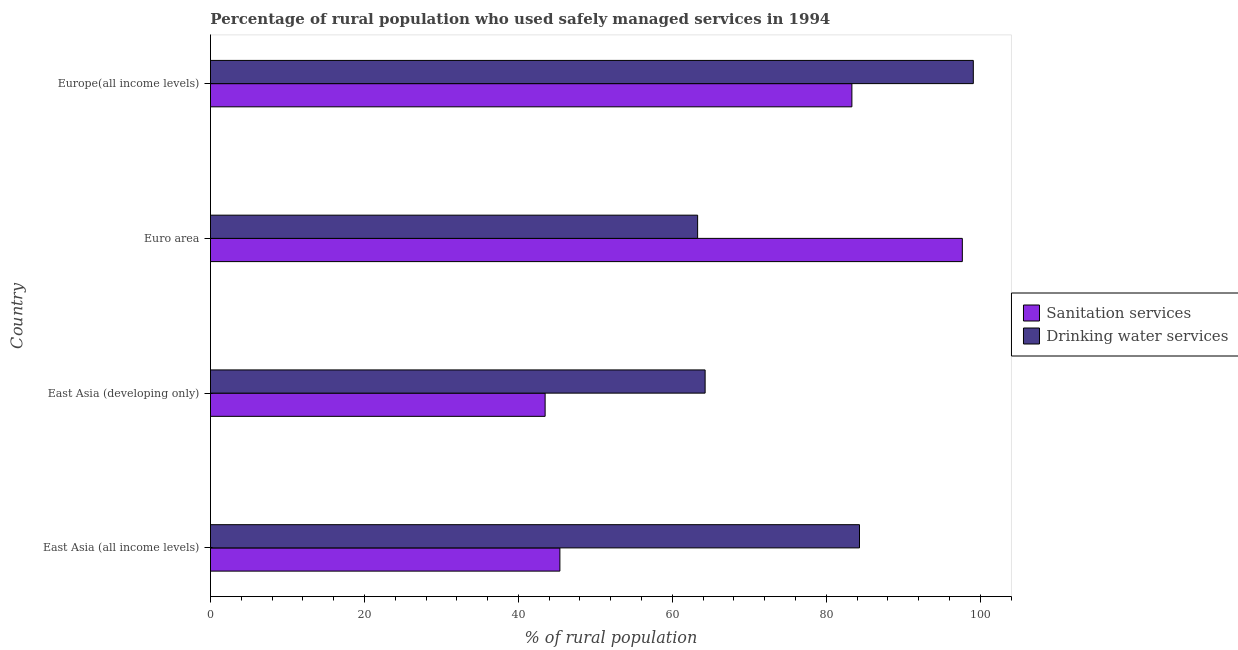How many different coloured bars are there?
Offer a very short reply. 2. Are the number of bars per tick equal to the number of legend labels?
Keep it short and to the point. Yes. What is the label of the 1st group of bars from the top?
Keep it short and to the point. Europe(all income levels). What is the percentage of rural population who used sanitation services in East Asia (developing only)?
Ensure brevity in your answer.  43.47. Across all countries, what is the maximum percentage of rural population who used sanitation services?
Ensure brevity in your answer.  97.67. Across all countries, what is the minimum percentage of rural population who used drinking water services?
Provide a succinct answer. 63.29. In which country was the percentage of rural population who used sanitation services maximum?
Your answer should be very brief. Euro area. What is the total percentage of rural population who used sanitation services in the graph?
Keep it short and to the point. 269.87. What is the difference between the percentage of rural population who used drinking water services in East Asia (developing only) and that in Europe(all income levels)?
Provide a succinct answer. -34.84. What is the difference between the percentage of rural population who used sanitation services in Europe(all income levels) and the percentage of rural population who used drinking water services in Euro area?
Give a very brief answer. 20.04. What is the average percentage of rural population who used drinking water services per country?
Your response must be concise. 77.74. What is the difference between the percentage of rural population who used drinking water services and percentage of rural population who used sanitation services in East Asia (developing only)?
Your answer should be compact. 20.79. In how many countries, is the percentage of rural population who used drinking water services greater than 96 %?
Provide a succinct answer. 1. What is the ratio of the percentage of rural population who used sanitation services in East Asia (all income levels) to that in Euro area?
Provide a succinct answer. 0.47. Is the percentage of rural population who used drinking water services in East Asia (developing only) less than that in Euro area?
Give a very brief answer. No. What is the difference between the highest and the second highest percentage of rural population who used sanitation services?
Your response must be concise. 14.35. What is the difference between the highest and the lowest percentage of rural population who used drinking water services?
Your answer should be compact. 35.82. In how many countries, is the percentage of rural population who used drinking water services greater than the average percentage of rural population who used drinking water services taken over all countries?
Your answer should be very brief. 2. Is the sum of the percentage of rural population who used drinking water services in East Asia (all income levels) and East Asia (developing only) greater than the maximum percentage of rural population who used sanitation services across all countries?
Make the answer very short. Yes. What does the 1st bar from the top in Euro area represents?
Give a very brief answer. Drinking water services. What does the 1st bar from the bottom in East Asia (all income levels) represents?
Offer a very short reply. Sanitation services. How many bars are there?
Ensure brevity in your answer.  8. What is the difference between two consecutive major ticks on the X-axis?
Offer a very short reply. 20. Where does the legend appear in the graph?
Give a very brief answer. Center right. What is the title of the graph?
Provide a short and direct response. Percentage of rural population who used safely managed services in 1994. Does "Under five" appear as one of the legend labels in the graph?
Keep it short and to the point. No. What is the label or title of the X-axis?
Make the answer very short. % of rural population. What is the % of rural population of Sanitation services in East Asia (all income levels)?
Give a very brief answer. 45.39. What is the % of rural population of Drinking water services in East Asia (all income levels)?
Give a very brief answer. 84.31. What is the % of rural population in Sanitation services in East Asia (developing only)?
Provide a succinct answer. 43.47. What is the % of rural population of Drinking water services in East Asia (developing only)?
Offer a terse response. 64.26. What is the % of rural population of Sanitation services in Euro area?
Offer a very short reply. 97.67. What is the % of rural population in Drinking water services in Euro area?
Your answer should be compact. 63.29. What is the % of rural population in Sanitation services in Europe(all income levels)?
Give a very brief answer. 83.33. What is the % of rural population of Drinking water services in Europe(all income levels)?
Your answer should be very brief. 99.1. Across all countries, what is the maximum % of rural population in Sanitation services?
Ensure brevity in your answer.  97.67. Across all countries, what is the maximum % of rural population in Drinking water services?
Your answer should be very brief. 99.1. Across all countries, what is the minimum % of rural population in Sanitation services?
Give a very brief answer. 43.47. Across all countries, what is the minimum % of rural population in Drinking water services?
Ensure brevity in your answer.  63.29. What is the total % of rural population in Sanitation services in the graph?
Offer a terse response. 269.87. What is the total % of rural population of Drinking water services in the graph?
Give a very brief answer. 310.97. What is the difference between the % of rural population in Sanitation services in East Asia (all income levels) and that in East Asia (developing only)?
Keep it short and to the point. 1.92. What is the difference between the % of rural population in Drinking water services in East Asia (all income levels) and that in East Asia (developing only)?
Provide a short and direct response. 20.05. What is the difference between the % of rural population in Sanitation services in East Asia (all income levels) and that in Euro area?
Offer a very short reply. -52.28. What is the difference between the % of rural population of Drinking water services in East Asia (all income levels) and that in Euro area?
Provide a short and direct response. 21.03. What is the difference between the % of rural population in Sanitation services in East Asia (all income levels) and that in Europe(all income levels)?
Make the answer very short. -37.93. What is the difference between the % of rural population in Drinking water services in East Asia (all income levels) and that in Europe(all income levels)?
Keep it short and to the point. -14.79. What is the difference between the % of rural population in Sanitation services in East Asia (developing only) and that in Euro area?
Your answer should be compact. -54.2. What is the difference between the % of rural population in Drinking water services in East Asia (developing only) and that in Euro area?
Your answer should be very brief. 0.97. What is the difference between the % of rural population of Sanitation services in East Asia (developing only) and that in Europe(all income levels)?
Your response must be concise. -39.85. What is the difference between the % of rural population in Drinking water services in East Asia (developing only) and that in Europe(all income levels)?
Give a very brief answer. -34.84. What is the difference between the % of rural population in Sanitation services in Euro area and that in Europe(all income levels)?
Offer a terse response. 14.35. What is the difference between the % of rural population in Drinking water services in Euro area and that in Europe(all income levels)?
Ensure brevity in your answer.  -35.82. What is the difference between the % of rural population of Sanitation services in East Asia (all income levels) and the % of rural population of Drinking water services in East Asia (developing only)?
Keep it short and to the point. -18.87. What is the difference between the % of rural population of Sanitation services in East Asia (all income levels) and the % of rural population of Drinking water services in Euro area?
Keep it short and to the point. -17.89. What is the difference between the % of rural population in Sanitation services in East Asia (all income levels) and the % of rural population in Drinking water services in Europe(all income levels)?
Your answer should be very brief. -53.71. What is the difference between the % of rural population in Sanitation services in East Asia (developing only) and the % of rural population in Drinking water services in Euro area?
Ensure brevity in your answer.  -19.81. What is the difference between the % of rural population in Sanitation services in East Asia (developing only) and the % of rural population in Drinking water services in Europe(all income levels)?
Offer a very short reply. -55.63. What is the difference between the % of rural population in Sanitation services in Euro area and the % of rural population in Drinking water services in Europe(all income levels)?
Give a very brief answer. -1.43. What is the average % of rural population of Sanitation services per country?
Provide a short and direct response. 67.47. What is the average % of rural population in Drinking water services per country?
Make the answer very short. 77.74. What is the difference between the % of rural population of Sanitation services and % of rural population of Drinking water services in East Asia (all income levels)?
Your response must be concise. -38.92. What is the difference between the % of rural population of Sanitation services and % of rural population of Drinking water services in East Asia (developing only)?
Offer a terse response. -20.79. What is the difference between the % of rural population of Sanitation services and % of rural population of Drinking water services in Euro area?
Keep it short and to the point. 34.39. What is the difference between the % of rural population in Sanitation services and % of rural population in Drinking water services in Europe(all income levels)?
Provide a succinct answer. -15.77. What is the ratio of the % of rural population in Sanitation services in East Asia (all income levels) to that in East Asia (developing only)?
Offer a very short reply. 1.04. What is the ratio of the % of rural population in Drinking water services in East Asia (all income levels) to that in East Asia (developing only)?
Offer a very short reply. 1.31. What is the ratio of the % of rural population of Sanitation services in East Asia (all income levels) to that in Euro area?
Offer a terse response. 0.46. What is the ratio of the % of rural population in Drinking water services in East Asia (all income levels) to that in Euro area?
Give a very brief answer. 1.33. What is the ratio of the % of rural population of Sanitation services in East Asia (all income levels) to that in Europe(all income levels)?
Your answer should be compact. 0.54. What is the ratio of the % of rural population in Drinking water services in East Asia (all income levels) to that in Europe(all income levels)?
Provide a succinct answer. 0.85. What is the ratio of the % of rural population of Sanitation services in East Asia (developing only) to that in Euro area?
Ensure brevity in your answer.  0.45. What is the ratio of the % of rural population in Drinking water services in East Asia (developing only) to that in Euro area?
Your answer should be very brief. 1.02. What is the ratio of the % of rural population in Sanitation services in East Asia (developing only) to that in Europe(all income levels)?
Provide a succinct answer. 0.52. What is the ratio of the % of rural population in Drinking water services in East Asia (developing only) to that in Europe(all income levels)?
Your answer should be very brief. 0.65. What is the ratio of the % of rural population in Sanitation services in Euro area to that in Europe(all income levels)?
Your answer should be compact. 1.17. What is the ratio of the % of rural population of Drinking water services in Euro area to that in Europe(all income levels)?
Make the answer very short. 0.64. What is the difference between the highest and the second highest % of rural population in Sanitation services?
Your answer should be very brief. 14.35. What is the difference between the highest and the second highest % of rural population of Drinking water services?
Offer a terse response. 14.79. What is the difference between the highest and the lowest % of rural population in Sanitation services?
Give a very brief answer. 54.2. What is the difference between the highest and the lowest % of rural population of Drinking water services?
Provide a succinct answer. 35.82. 